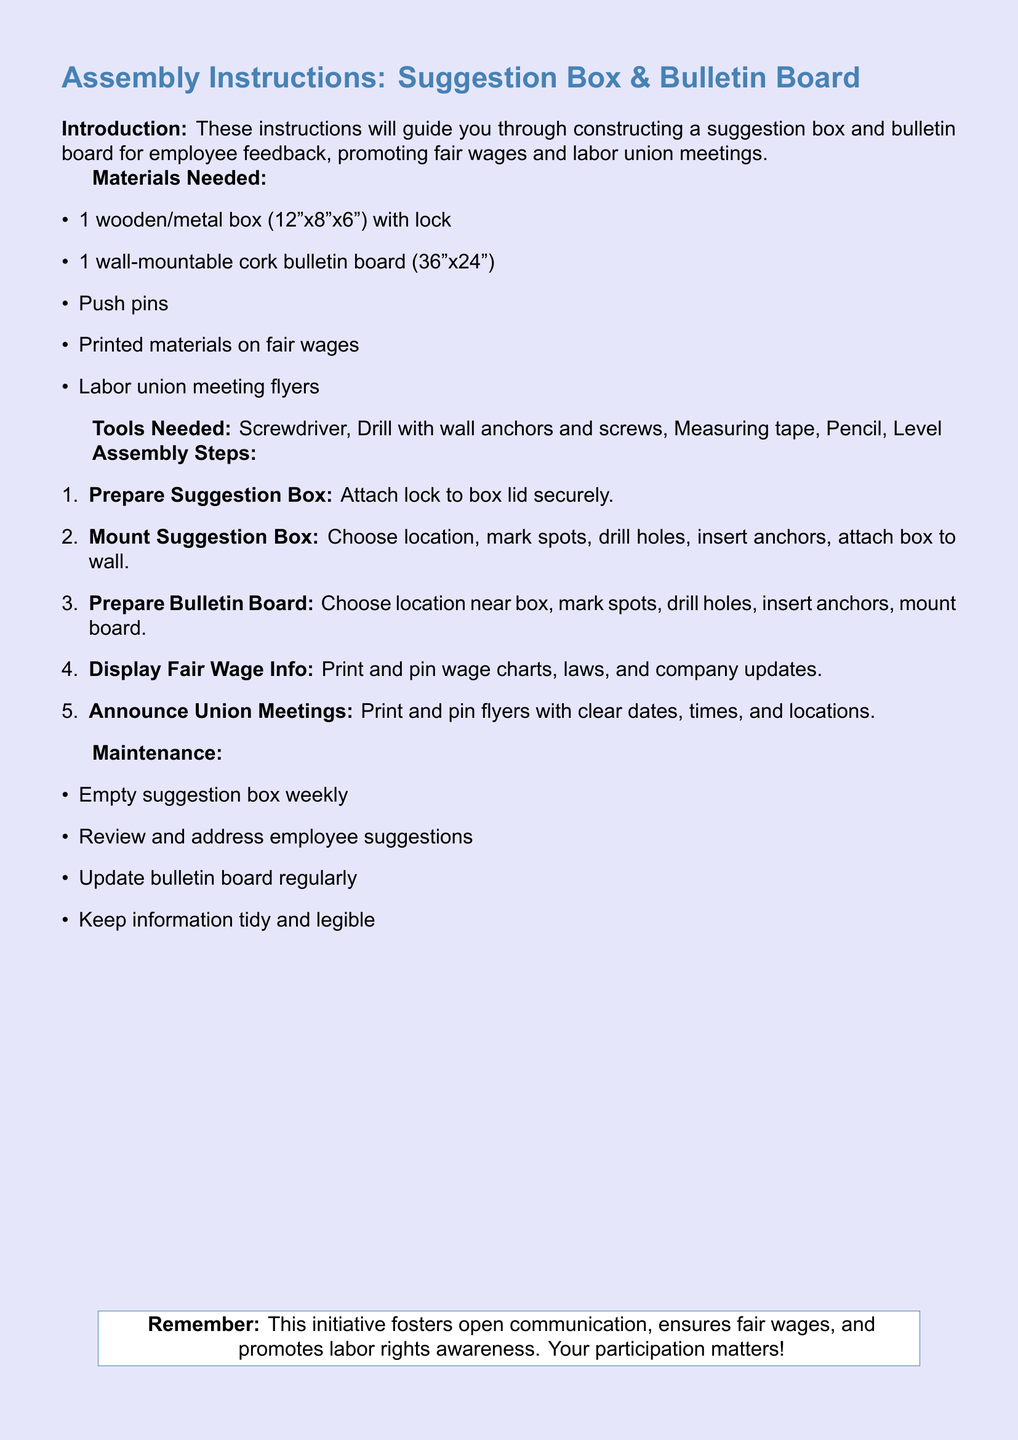what are the dimensions of the suggestion box? The dimensions of the suggestion box are specified as 12"x8"x6" in the materials list.
Answer: 12"x8"x6" how many push pins are needed? The document does not specify a number of push pins; it simply lists them as a needed material.
Answer: Not specified what should be displayed on the bulletin board? The document states that fair wage information and union meeting flyers should be displayed on the bulletin board.
Answer: Fair wage information and union meeting flyers how often should the suggestion box be emptied? The maintenance section clarifies that the suggestion box should be emptied weekly.
Answer: Weekly what tools are required for assembly? The document lists specific tools needed for assembly: screwdriver, drill, measuring tape, pencil, and level.
Answer: Screwdriver, drill, measuring tape, pencil, level what is the purpose of this initiative? The introduction describes the purpose as fostering open communication, ensuring fair wages, and promoting labor rights awareness.
Answer: Open communication, fair wages, labor rights awareness how large is the bulletin board? The bulletin board's dimensions are provided in the materials section as 36"x24".
Answer: 36"x24" what should be done with employee suggestions? The maintenance section states that employee suggestions should be reviewed and addressed.
Answer: Review and address where should the bulletin board be mounted? The instructions indicate that the bulletin board should be mounted near the suggestion box.
Answer: Near the suggestion box 